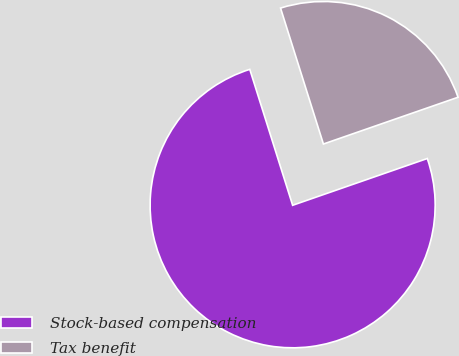Convert chart to OTSL. <chart><loc_0><loc_0><loc_500><loc_500><pie_chart><fcel>Stock-based compensation<fcel>Tax benefit<nl><fcel>75.46%<fcel>24.54%<nl></chart> 